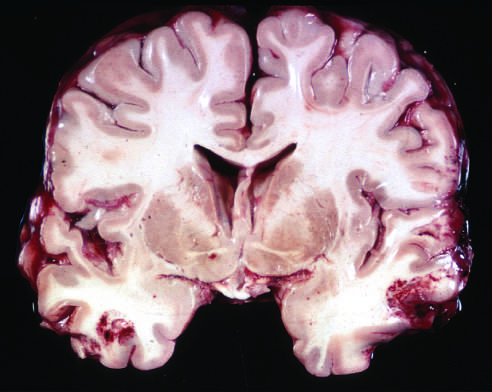re acute contusions present in both temporal lobes, with areas of hemorrhage and tissue disruption?
Answer the question using a single word or phrase. Yes 